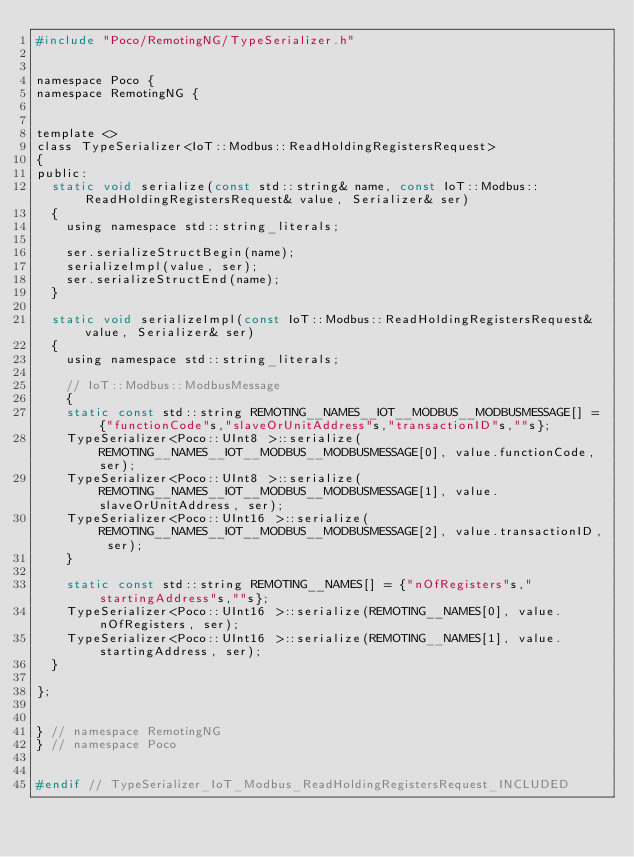Convert code to text. <code><loc_0><loc_0><loc_500><loc_500><_C_>#include "Poco/RemotingNG/TypeSerializer.h"


namespace Poco {
namespace RemotingNG {


template <>
class TypeSerializer<IoT::Modbus::ReadHoldingRegistersRequest>
{
public:
	static void serialize(const std::string& name, const IoT::Modbus::ReadHoldingRegistersRequest& value, Serializer& ser)
	{
		using namespace std::string_literals;
		
		ser.serializeStructBegin(name);
		serializeImpl(value, ser);
		ser.serializeStructEnd(name);
	}

	static void serializeImpl(const IoT::Modbus::ReadHoldingRegistersRequest& value, Serializer& ser)
	{
		using namespace std::string_literals;
		
		// IoT::Modbus::ModbusMessage
		{
		static const std::string REMOTING__NAMES__IOT__MODBUS__MODBUSMESSAGE[] = {"functionCode"s,"slaveOrUnitAddress"s,"transactionID"s,""s};
		TypeSerializer<Poco::UInt8 >::serialize(REMOTING__NAMES__IOT__MODBUS__MODBUSMESSAGE[0], value.functionCode, ser);
		TypeSerializer<Poco::UInt8 >::serialize(REMOTING__NAMES__IOT__MODBUS__MODBUSMESSAGE[1], value.slaveOrUnitAddress, ser);
		TypeSerializer<Poco::UInt16 >::serialize(REMOTING__NAMES__IOT__MODBUS__MODBUSMESSAGE[2], value.transactionID, ser);
		}
		
		static const std::string REMOTING__NAMES[] = {"nOfRegisters"s,"startingAddress"s,""s};
		TypeSerializer<Poco::UInt16 >::serialize(REMOTING__NAMES[0], value.nOfRegisters, ser);
		TypeSerializer<Poco::UInt16 >::serialize(REMOTING__NAMES[1], value.startingAddress, ser);
	}

};


} // namespace RemotingNG
} // namespace Poco


#endif // TypeSerializer_IoT_Modbus_ReadHoldingRegistersRequest_INCLUDED

</code> 